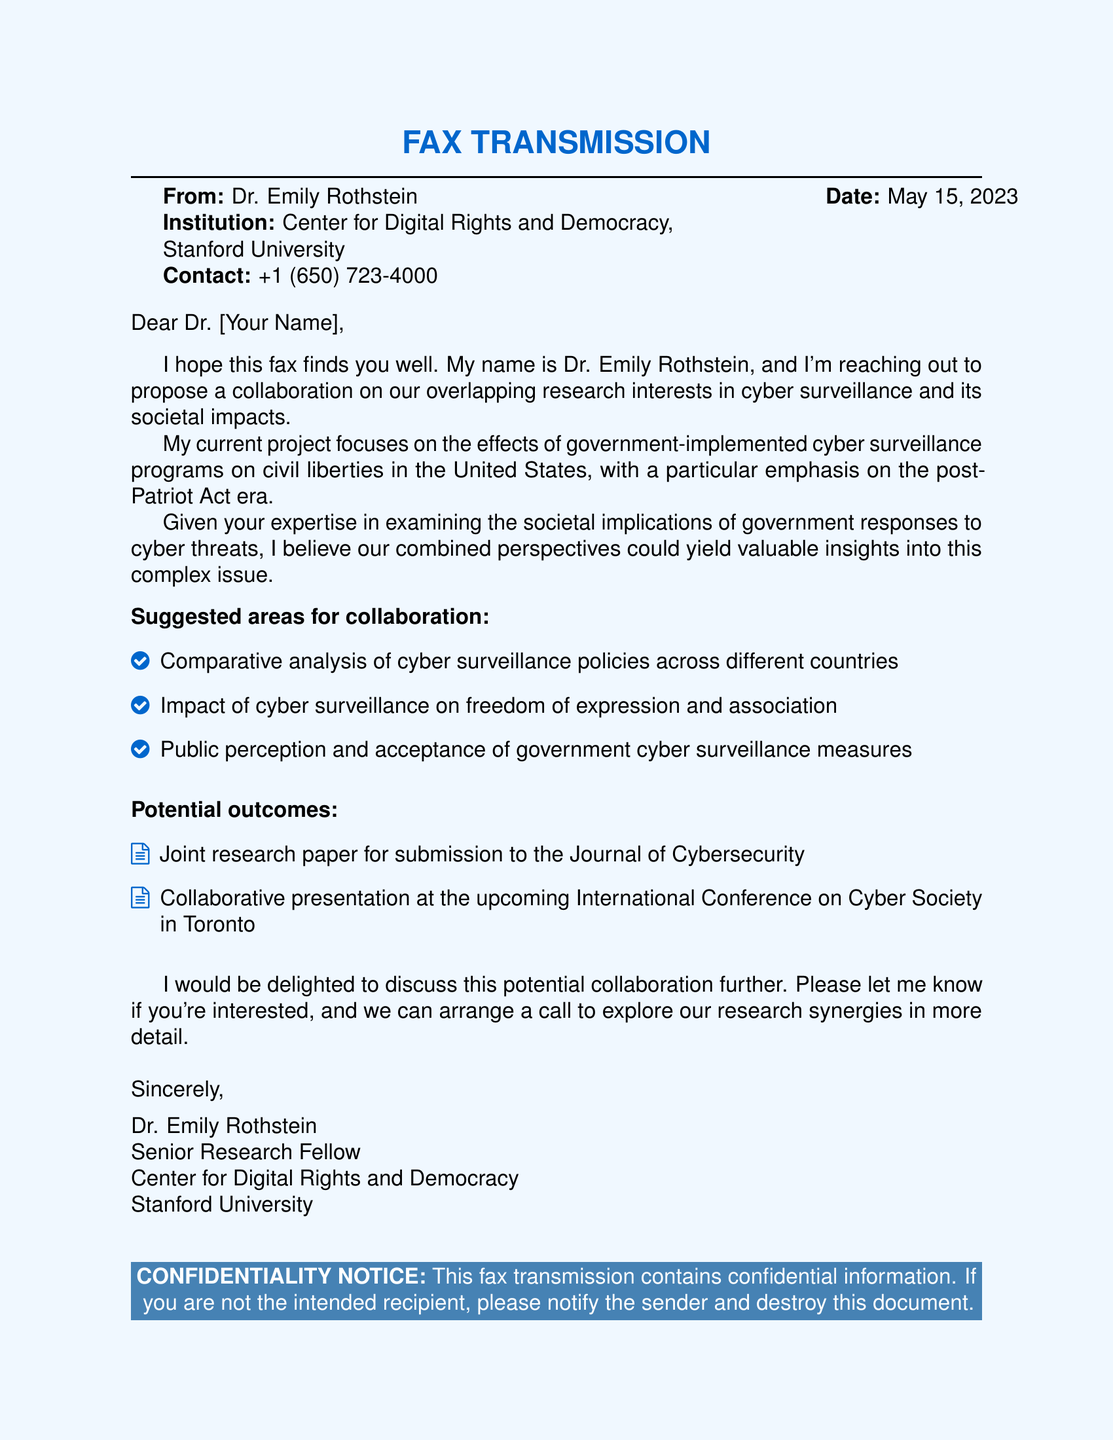What is the sender's name? The sender's name is mentioned at the beginning of the fax.
Answer: Dr. Emily Rothstein What is the date of the fax? The date is specified in the upper right corner of the document.
Answer: May 15, 2023 Which institution is Dr. Rothstein affiliated with? The institution is listed right below the sender's name.
Answer: Center for Digital Rights and Democracy, Stanford University What is one suggested area for collaboration? The areas for collaboration are listed in a bullet format within the document.
Answer: Comparative analysis of cyber surveillance policies across different countries What is one potential outcome of the collaboration? The potential outcomes are also presented in bullet points within the document.
Answer: Joint research paper for submission to the Journal of Cybersecurity What is the fax about? The overall theme of the fax is described in the opening paragraphs.
Answer: Collaboration on research about cyber surveillance and civil liberties What is Dr. Rothstein's title? The title is stated in connection with her name at the end of the fax.
Answer: Senior Research Fellow What was emphasized in Dr. Rothstein's project? The focus of Dr. Rothstein's project is described in the context of her research interests.
Answer: Effects of government-implemented cyber surveillance programs on civil liberties What conference is mentioned in the document? The name of the conference is provided in the list of potential outcomes.
Answer: International Conference on Cyber Society in Toronto 